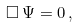<formula> <loc_0><loc_0><loc_500><loc_500>\Box \, \Psi = 0 \, ,</formula> 